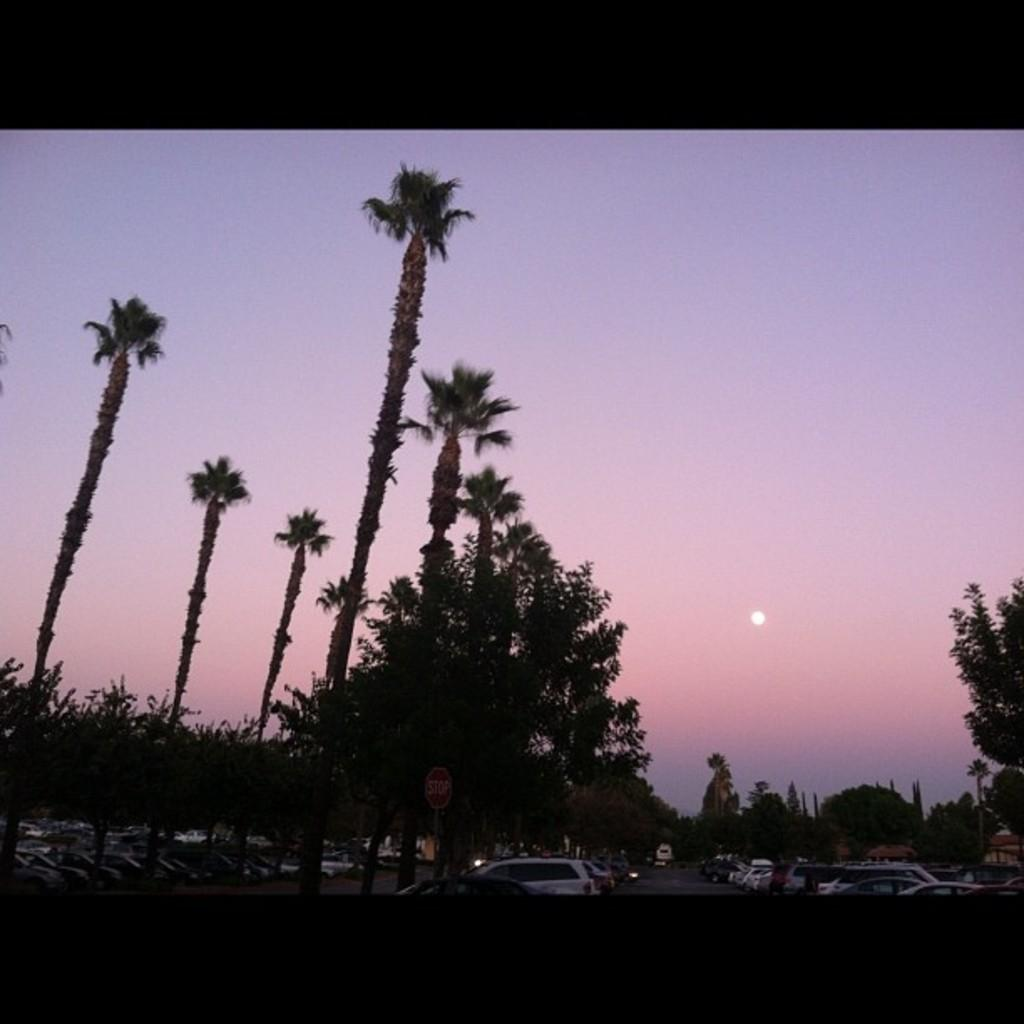What is the setting of the image? The image has an outside view. What can be seen in the foreground of the image? There are trees and vehicles in the foreground of the image. What is visible in the background of the image? The sky is visible in the background of the image. What level of baseball skills does the beginner in the image possess? There is no person or mention of baseball in the image, so it is not possible to determine the level of baseball skills of a beginner. 